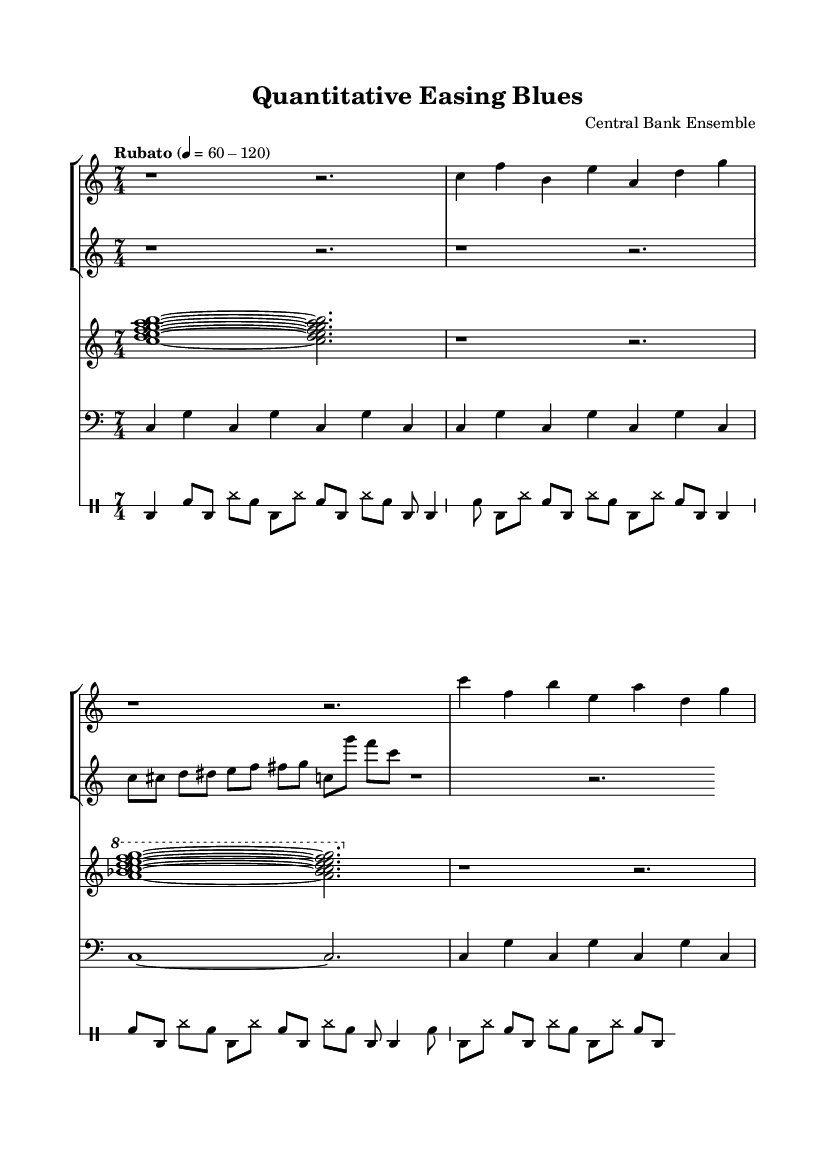What is the time signature of this music? The time signature is 7/4, as indicated at the beginning of the sheet music. It is shown in the global block specifying the meter.
Answer: 7/4 What is the tempo marking of this composition? The tempo marking is "Rubato," which suggests expressive timing, allowing for flexible tempo. The beats per minute are indicated as varying from 60 to 120.
Answer: Rubato How many instruments are featured in this piece? There are four distinct instruments indicated: trumpet, saxophone, piano, and bass. Each is represented by a separate staff.
Answer: Four What is the clef used for the saxophone staff? The saxophone uses a treble clef, as indicated in its corresponding staff at the beginning.
Answer: Treble What type of jazz does this composition embody? This composition embodies avant-garde jazz, which is characterized by experimental tendencies and complexity, both musically and thematically, as derived from its title "Quantitative Easing Blues."
Answer: Avant-garde Which instrument has the longest sustained note? The bass instrument has a long sustained note, indicated by the whole note (c1) that lasts for two beats. It is visually evident as it spans a greater duration compared to the other parts.
Answer: Bass What rhythmic pattern does the drum part predominantly follow? The drum part predominantly follows a bass drum and snare pattern in an alternating sequence with eighth notes, creating a complex rhythmic backdrop conducive to the improvisational nature of jazz.
Answer: Alternating bass and snare 